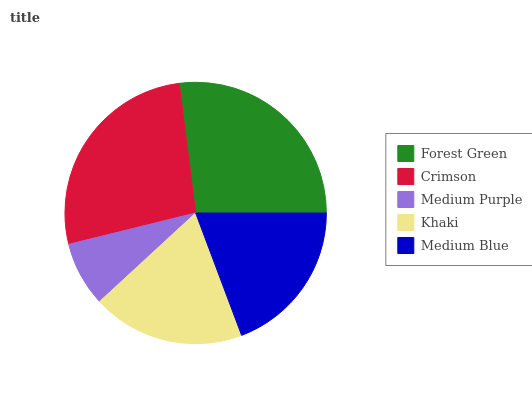Is Medium Purple the minimum?
Answer yes or no. Yes. Is Forest Green the maximum?
Answer yes or no. Yes. Is Crimson the minimum?
Answer yes or no. No. Is Crimson the maximum?
Answer yes or no. No. Is Forest Green greater than Crimson?
Answer yes or no. Yes. Is Crimson less than Forest Green?
Answer yes or no. Yes. Is Crimson greater than Forest Green?
Answer yes or no. No. Is Forest Green less than Crimson?
Answer yes or no. No. Is Medium Blue the high median?
Answer yes or no. Yes. Is Medium Blue the low median?
Answer yes or no. Yes. Is Medium Purple the high median?
Answer yes or no. No. Is Khaki the low median?
Answer yes or no. No. 